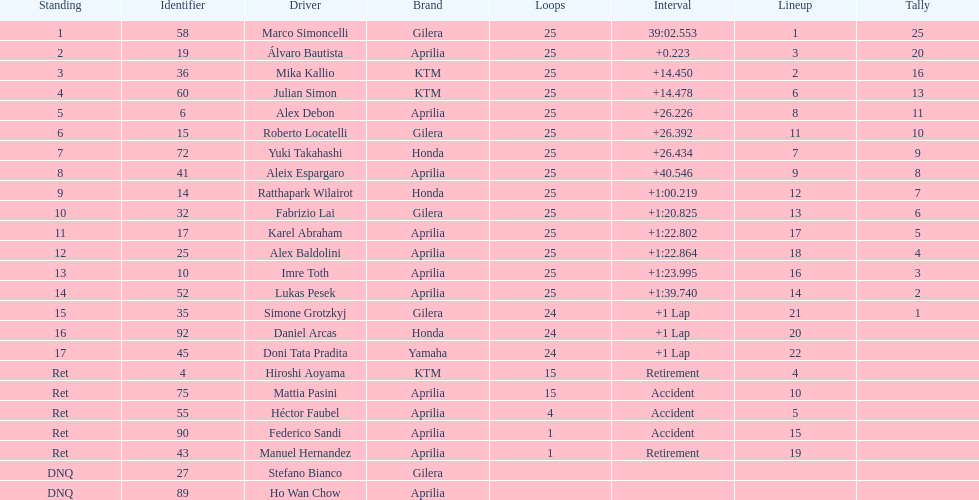How many riders manufacturer is honda? 3. 